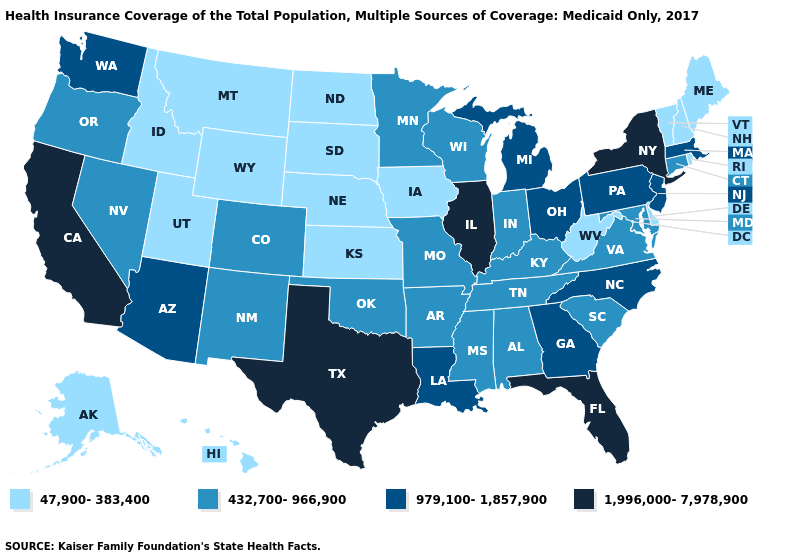Does Iowa have the highest value in the MidWest?
Be succinct. No. Name the states that have a value in the range 47,900-383,400?
Give a very brief answer. Alaska, Delaware, Hawaii, Idaho, Iowa, Kansas, Maine, Montana, Nebraska, New Hampshire, North Dakota, Rhode Island, South Dakota, Utah, Vermont, West Virginia, Wyoming. Name the states that have a value in the range 1,996,000-7,978,900?
Answer briefly. California, Florida, Illinois, New York, Texas. Name the states that have a value in the range 979,100-1,857,900?
Concise answer only. Arizona, Georgia, Louisiana, Massachusetts, Michigan, New Jersey, North Carolina, Ohio, Pennsylvania, Washington. Name the states that have a value in the range 432,700-966,900?
Short answer required. Alabama, Arkansas, Colorado, Connecticut, Indiana, Kentucky, Maryland, Minnesota, Mississippi, Missouri, Nevada, New Mexico, Oklahoma, Oregon, South Carolina, Tennessee, Virginia, Wisconsin. Does Nevada have the same value as Michigan?
Quick response, please. No. What is the highest value in the USA?
Short answer required. 1,996,000-7,978,900. Does Wisconsin have the highest value in the USA?
Keep it brief. No. What is the value of Louisiana?
Write a very short answer. 979,100-1,857,900. Name the states that have a value in the range 1,996,000-7,978,900?
Keep it brief. California, Florida, Illinois, New York, Texas. Among the states that border New Hampshire , which have the highest value?
Short answer required. Massachusetts. Name the states that have a value in the range 1,996,000-7,978,900?
Concise answer only. California, Florida, Illinois, New York, Texas. What is the value of Georgia?
Give a very brief answer. 979,100-1,857,900. Does the first symbol in the legend represent the smallest category?
Concise answer only. Yes. Is the legend a continuous bar?
Concise answer only. No. 